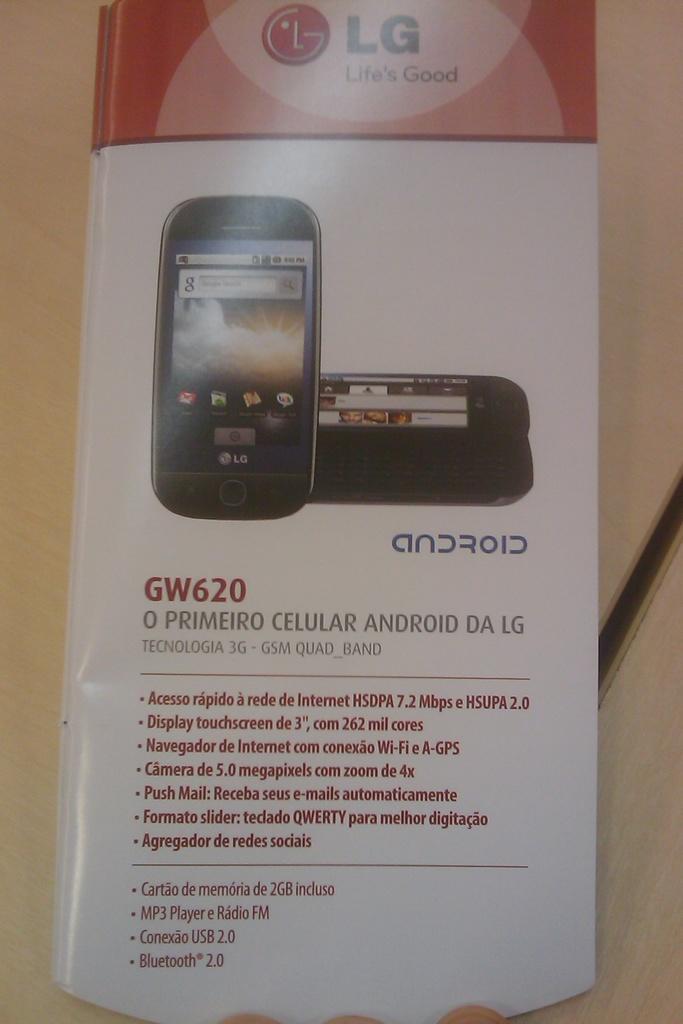What model phone is being advertised?
Your answer should be very brief. Gw620. 